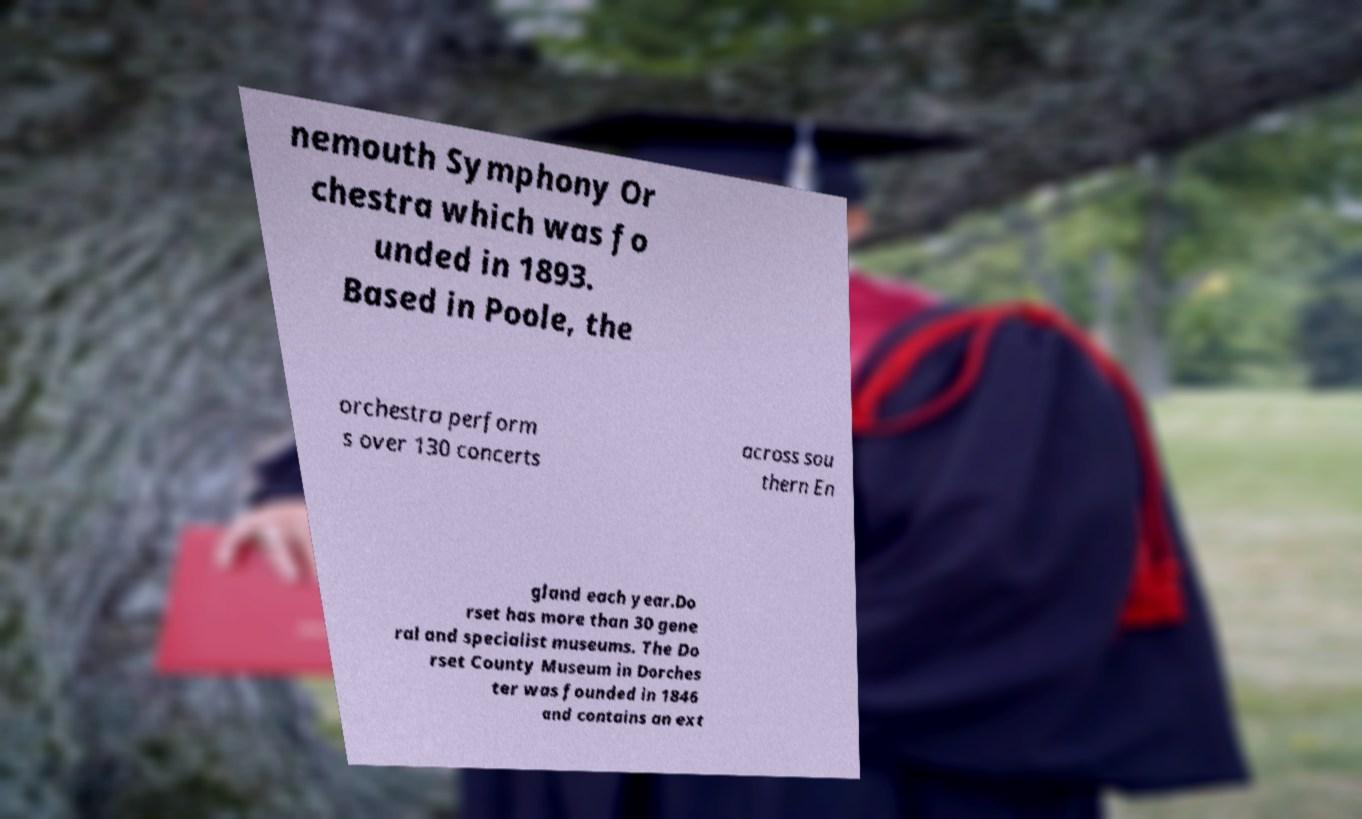Please read and relay the text visible in this image. What does it say? nemouth Symphony Or chestra which was fo unded in 1893. Based in Poole, the orchestra perform s over 130 concerts across sou thern En gland each year.Do rset has more than 30 gene ral and specialist museums. The Do rset County Museum in Dorches ter was founded in 1846 and contains an ext 